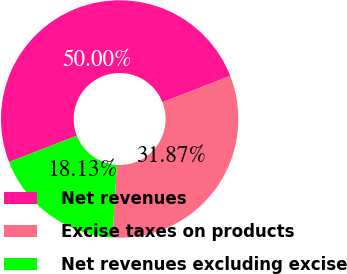Convert chart to OTSL. <chart><loc_0><loc_0><loc_500><loc_500><pie_chart><fcel>Net revenues<fcel>Excise taxes on products<fcel>Net revenues excluding excise<nl><fcel>50.0%<fcel>31.87%<fcel>18.13%<nl></chart> 